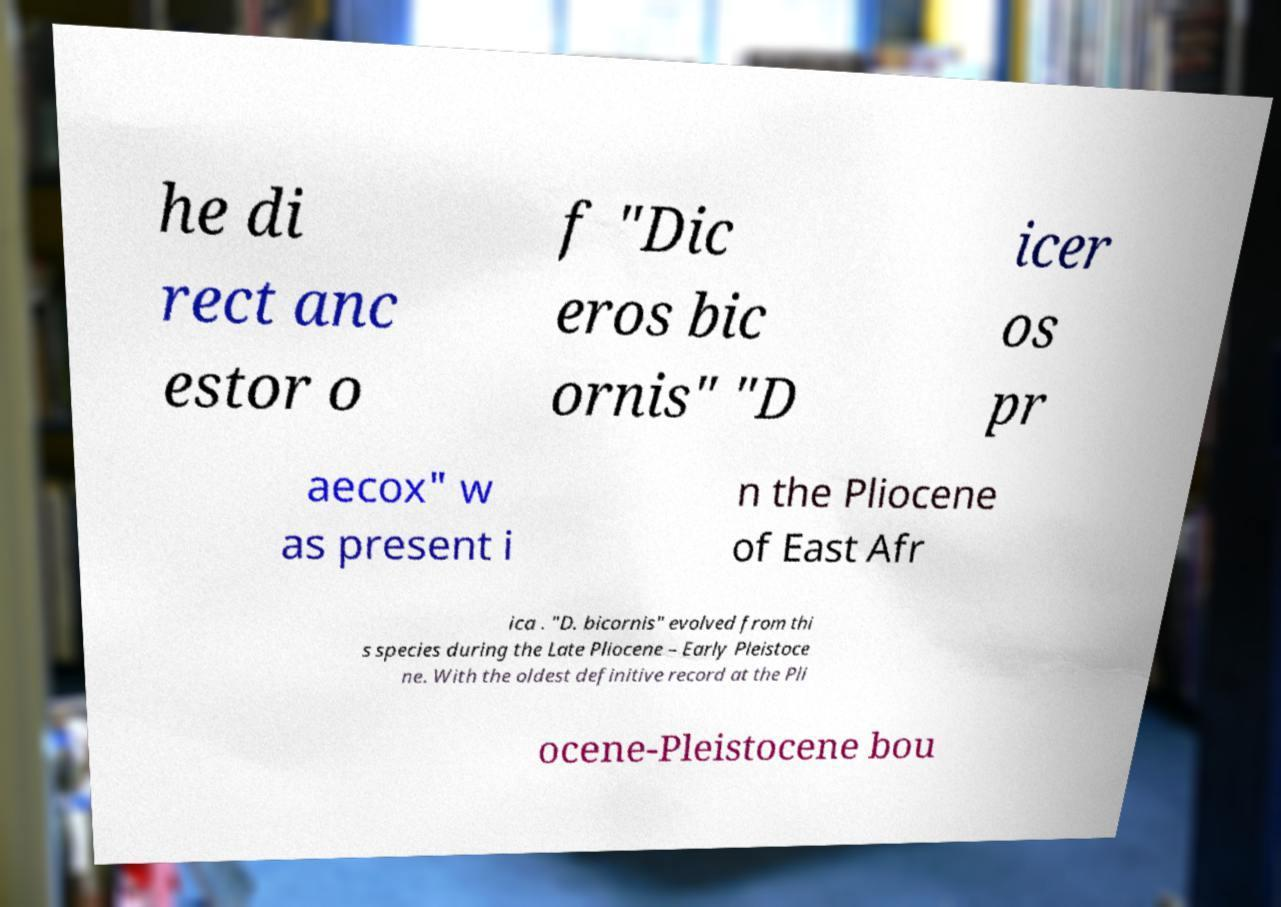Can you accurately transcribe the text from the provided image for me? he di rect anc estor o f "Dic eros bic ornis" "D icer os pr aecox" w as present i n the Pliocene of East Afr ica . "D. bicornis" evolved from thi s species during the Late Pliocene – Early Pleistoce ne. With the oldest definitive record at the Pli ocene-Pleistocene bou 